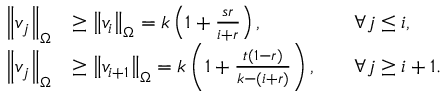<formula> <loc_0><loc_0><loc_500><loc_500>\begin{array} { r l r l } { \left \| v _ { j } \right \| _ { \Omega } } & { \geq \left \| v _ { i } \right \| _ { \Omega } = k \left ( 1 + \frac { s r } { i + r } \right ) , } & & { \forall j \leq i , } \\ { \left \| v _ { j } \right \| _ { \Omega } } & { \geq \left \| v _ { i + 1 } \right \| _ { \Omega } = k \left ( 1 + \frac { t ( 1 - r ) } { k - ( i + r ) } \right ) , } & & { \forall j \geq i + 1 . } \end{array}</formula> 